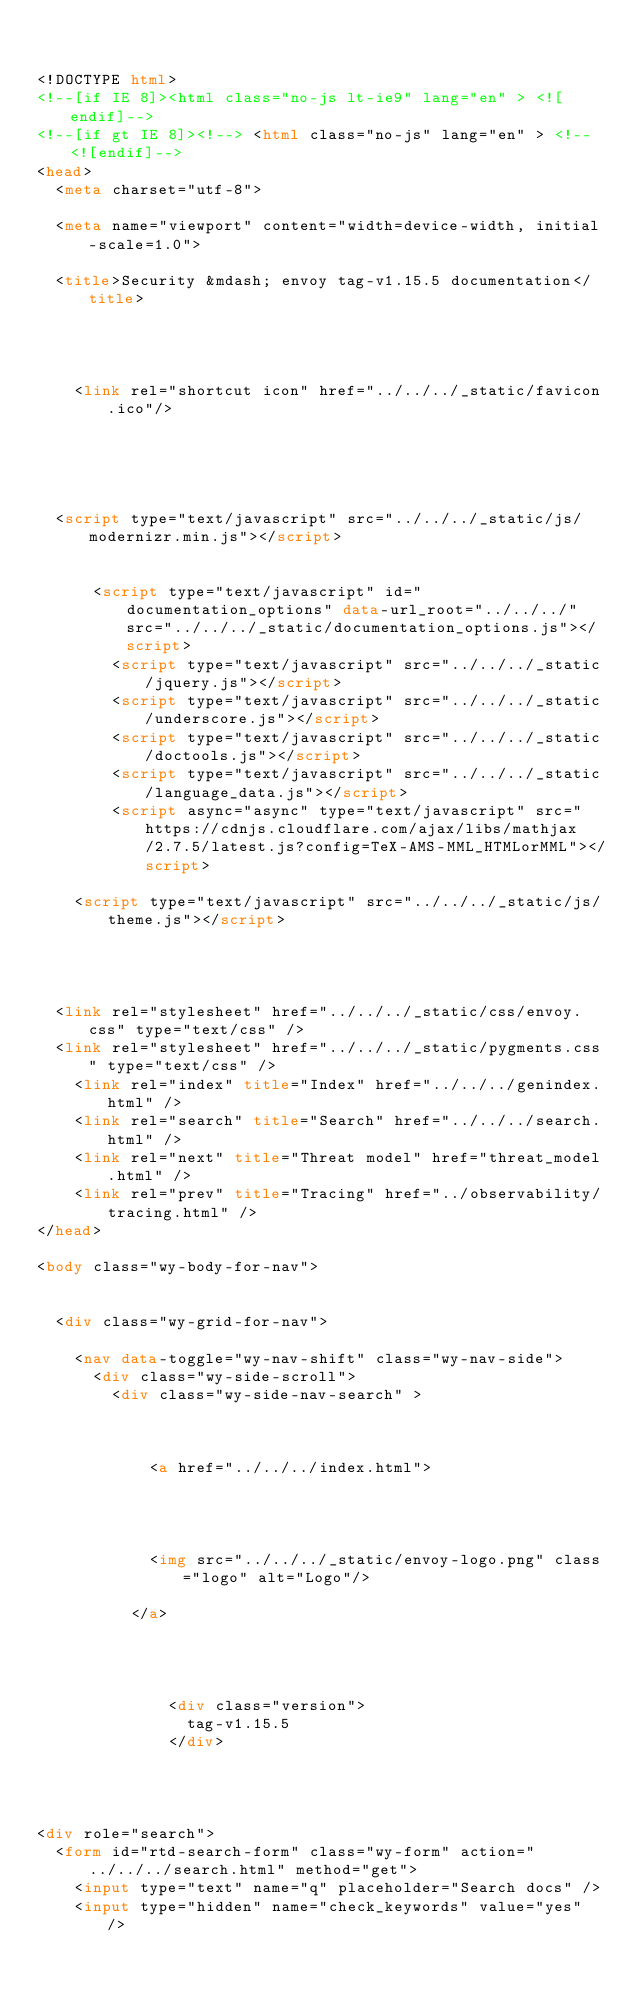Convert code to text. <code><loc_0><loc_0><loc_500><loc_500><_HTML_>

<!DOCTYPE html>
<!--[if IE 8]><html class="no-js lt-ie9" lang="en" > <![endif]-->
<!--[if gt IE 8]><!--> <html class="no-js" lang="en" > <!--<![endif]-->
<head>
  <meta charset="utf-8">
  
  <meta name="viewport" content="width=device-width, initial-scale=1.0">
  
  <title>Security &mdash; envoy tag-v1.15.5 documentation</title>
  

  
  
    <link rel="shortcut icon" href="../../../_static/favicon.ico"/>
  
  
  

  
  <script type="text/javascript" src="../../../_static/js/modernizr.min.js"></script>
  
    
      <script type="text/javascript" id="documentation_options" data-url_root="../../../" src="../../../_static/documentation_options.js"></script>
        <script type="text/javascript" src="../../../_static/jquery.js"></script>
        <script type="text/javascript" src="../../../_static/underscore.js"></script>
        <script type="text/javascript" src="../../../_static/doctools.js"></script>
        <script type="text/javascript" src="../../../_static/language_data.js"></script>
        <script async="async" type="text/javascript" src="https://cdnjs.cloudflare.com/ajax/libs/mathjax/2.7.5/latest.js?config=TeX-AMS-MML_HTMLorMML"></script>
    
    <script type="text/javascript" src="../../../_static/js/theme.js"></script>

    

  
  <link rel="stylesheet" href="../../../_static/css/envoy.css" type="text/css" />
  <link rel="stylesheet" href="../../../_static/pygments.css" type="text/css" />
    <link rel="index" title="Index" href="../../../genindex.html" />
    <link rel="search" title="Search" href="../../../search.html" />
    <link rel="next" title="Threat model" href="threat_model.html" />
    <link rel="prev" title="Tracing" href="../observability/tracing.html" /> 
</head>

<body class="wy-body-for-nav">

   
  <div class="wy-grid-for-nav">
    
    <nav data-toggle="wy-nav-shift" class="wy-nav-side">
      <div class="wy-side-scroll">
        <div class="wy-side-nav-search" >
          

          
            <a href="../../../index.html">
          

          
            
            <img src="../../../_static/envoy-logo.png" class="logo" alt="Logo"/>
          
          </a>

          
            
            
              <div class="version">
                tag-v1.15.5
              </div>
            
          

          
<div role="search">
  <form id="rtd-search-form" class="wy-form" action="../../../search.html" method="get">
    <input type="text" name="q" placeholder="Search docs" />
    <input type="hidden" name="check_keywords" value="yes" /></code> 